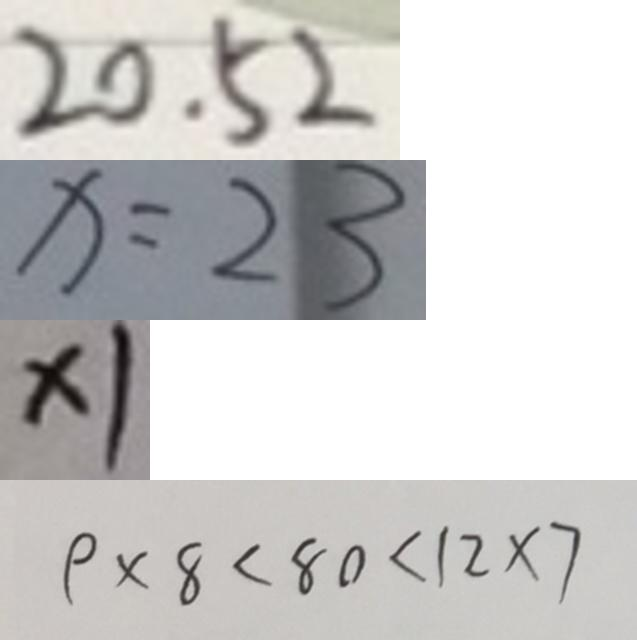Convert formula to latex. <formula><loc_0><loc_0><loc_500><loc_500>2 0 . 5 2 
 x = 2 3 
 \times 1 
 9 \times 8 < 8 0 < 1 2 \times 7</formula> 